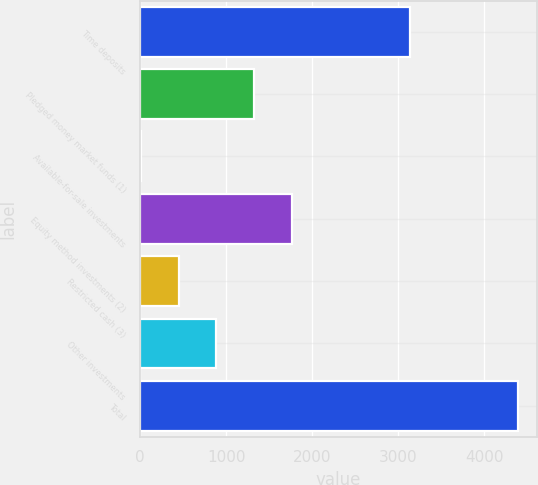<chart> <loc_0><loc_0><loc_500><loc_500><bar_chart><fcel>Time deposits<fcel>Pledged money market funds (1)<fcel>Available-for-sale investments<fcel>Equity method investments (2)<fcel>Restricted cash (3)<fcel>Other investments<fcel>Total<nl><fcel>3135<fcel>1325.4<fcel>9<fcel>1764.2<fcel>447.8<fcel>886.6<fcel>4397<nl></chart> 